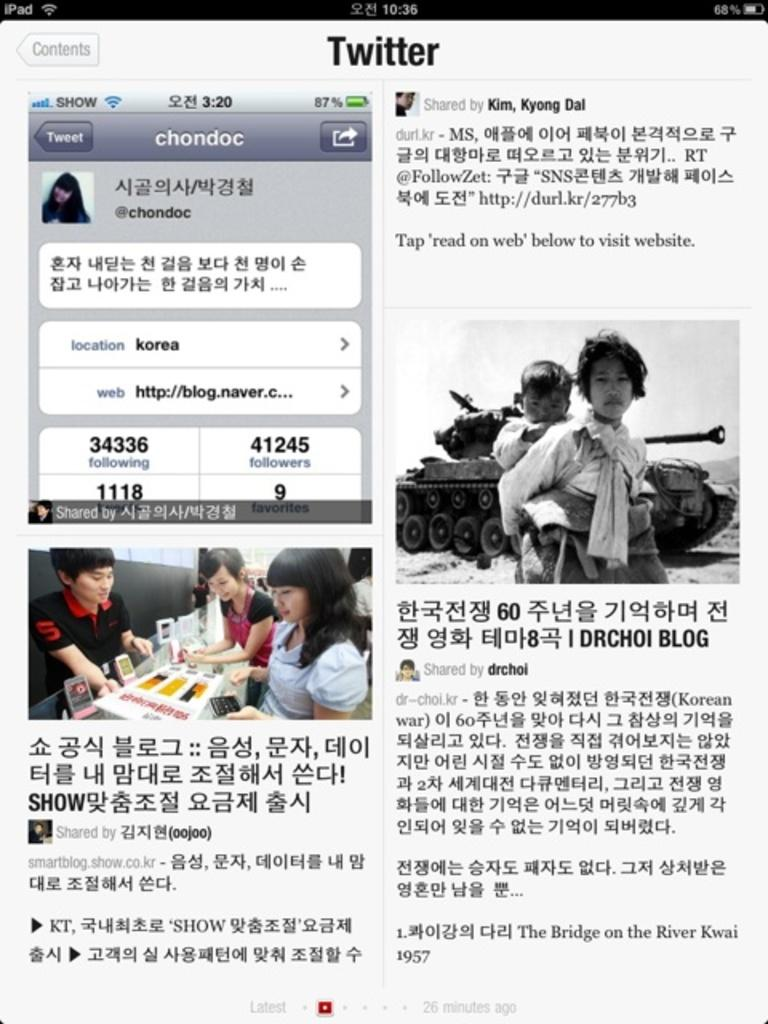What type of content is displayed on the web page? The image is a web page, which contains an image and text. Can you describe the image on the web page? Unfortunately, the specific content of the image cannot be determined from the provided facts. What information is conveyed through the text on the web page? The details of the text on the web page cannot be determined from the provided facts. How does the bear use the rake in the image? There is no bear or rake present in the image, as it is a web page containing an image and text. 